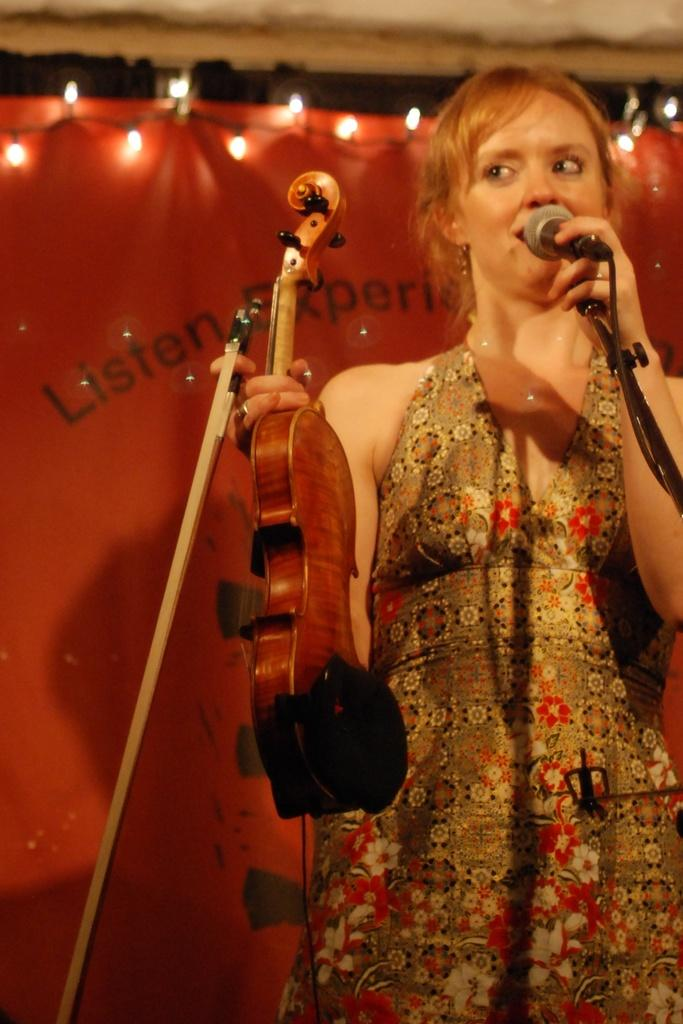Who is the main subject in the image? There is a person in the image. What is the person doing in the image? The person is standing in front of a mic and holding a violin. What else can be seen in the image? There is a banner in the image, and lights are attached to the banner. What type of butter is being used to play the violin in the image? There is no butter present in the image, and the person is playing the violin with their hands, not butter. 